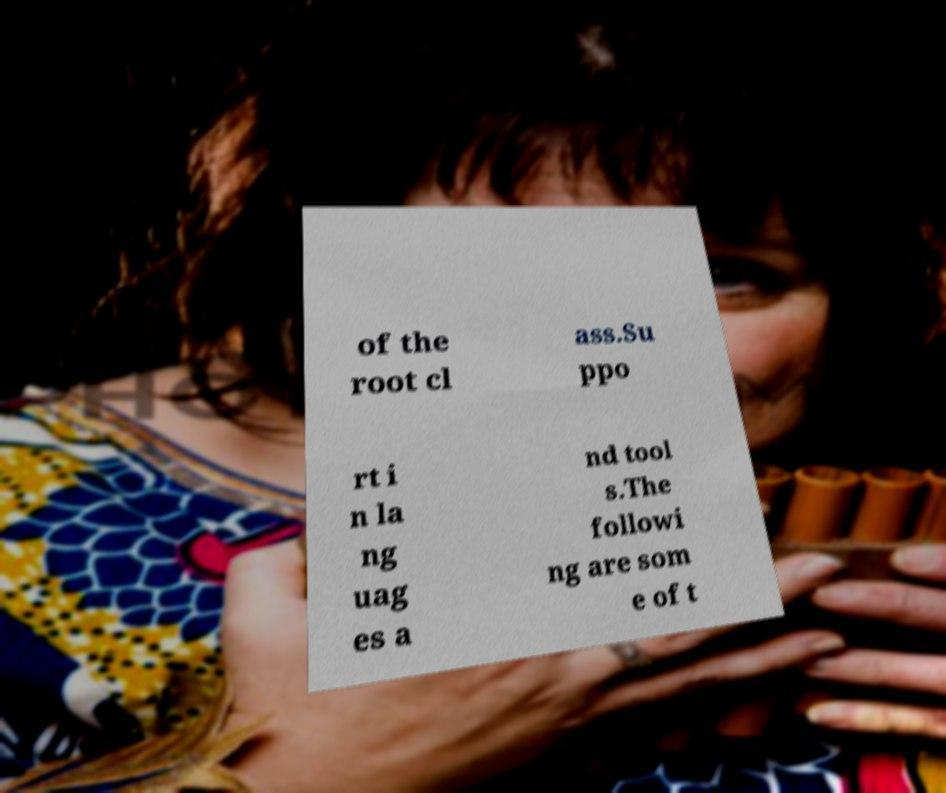There's text embedded in this image that I need extracted. Can you transcribe it verbatim? of the root cl ass.Su ppo rt i n la ng uag es a nd tool s.The followi ng are som e of t 